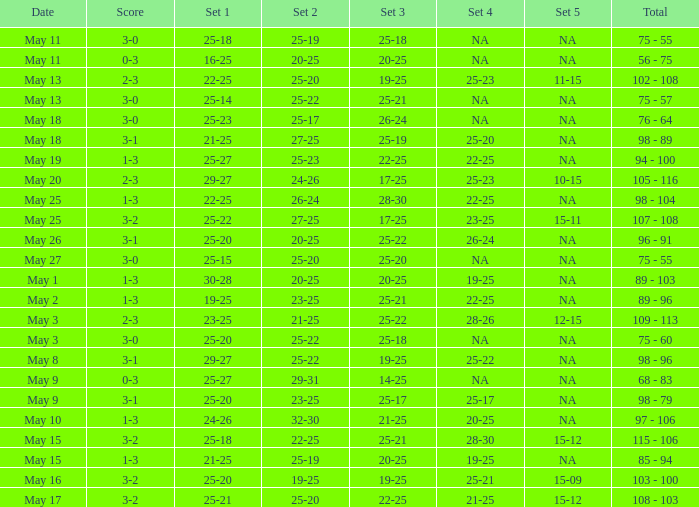How can set 2 be defined with 1 set of numbers between 21-25 and 4 sets of numbers between 25-20? 27-25. 